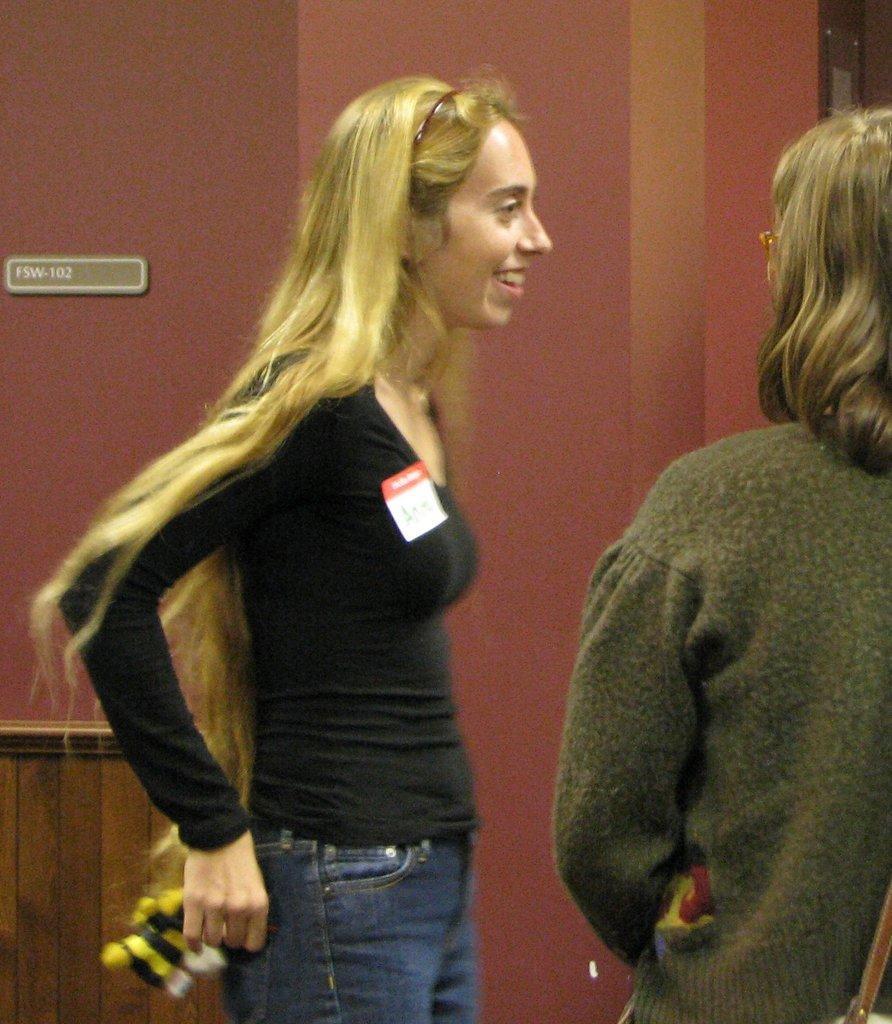Describe this image in one or two sentences. This is the woman standing and smiling. She wore a T-shirt, trouser and holding an object in her hand. This looks like a board, which is attached to the wall. I think this is a pillar. Here is another woman standing. 